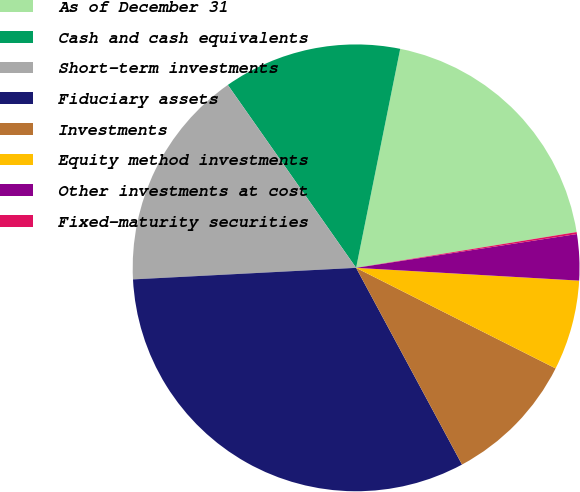<chart> <loc_0><loc_0><loc_500><loc_500><pie_chart><fcel>As of December 31<fcel>Cash and cash equivalents<fcel>Short-term investments<fcel>Fiduciary assets<fcel>Investments<fcel>Equity method investments<fcel>Other investments at cost<fcel>Fixed-maturity securities<nl><fcel>19.28%<fcel>12.9%<fcel>16.09%<fcel>32.04%<fcel>9.71%<fcel>6.52%<fcel>3.33%<fcel>0.14%<nl></chart> 